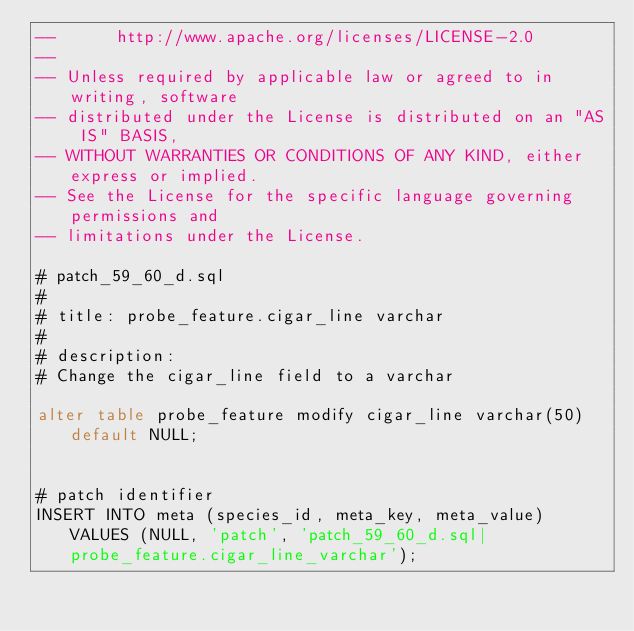Convert code to text. <code><loc_0><loc_0><loc_500><loc_500><_SQL_>--      http://www.apache.org/licenses/LICENSE-2.0
-- 
-- Unless required by applicable law or agreed to in writing, software
-- distributed under the License is distributed on an "AS IS" BASIS,
-- WITHOUT WARRANTIES OR CONDITIONS OF ANY KIND, either express or implied.
-- See the License for the specific language governing permissions and
-- limitations under the License.

# patch_59_60_d.sql
#
# title: probe_feature.cigar_line varchar
#
# description:
# Change the cigar_line field to a varchar

alter table probe_feature modify cigar_line varchar(50) default NULL;


# patch identifier
INSERT INTO meta (species_id, meta_key, meta_value) VALUES (NULL, 'patch', 'patch_59_60_d.sql|probe_feature.cigar_line_varchar');


</code> 